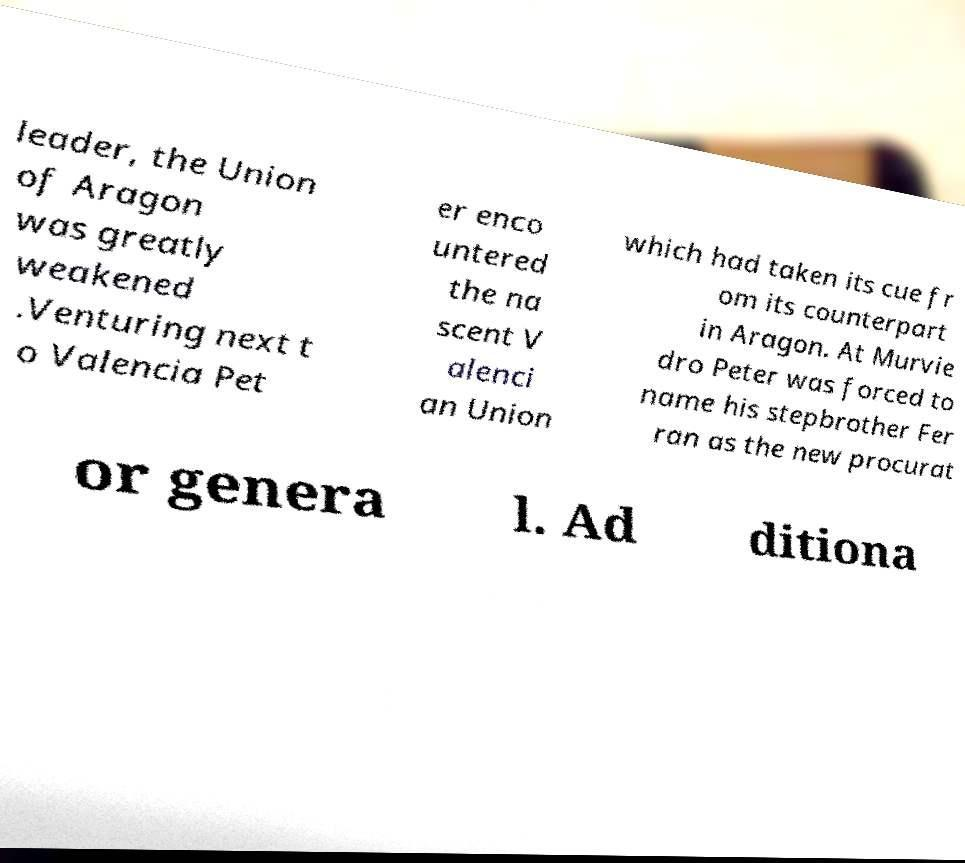I need the written content from this picture converted into text. Can you do that? leader, the Union of Aragon was greatly weakened .Venturing next t o Valencia Pet er enco untered the na scent V alenci an Union which had taken its cue fr om its counterpart in Aragon. At Murvie dro Peter was forced to name his stepbrother Fer ran as the new procurat or genera l. Ad ditiona 